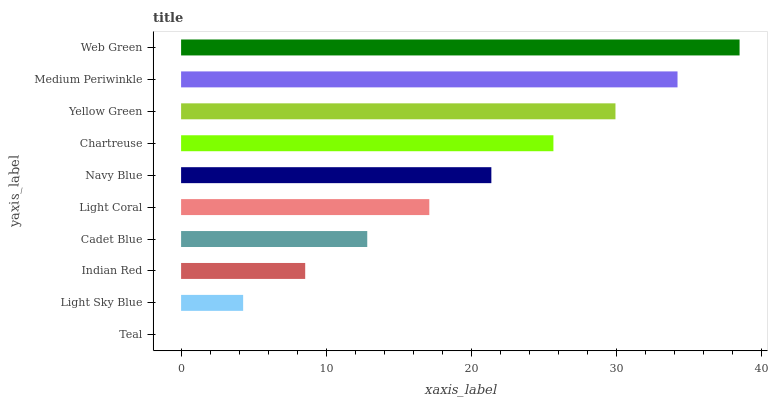Is Teal the minimum?
Answer yes or no. Yes. Is Web Green the maximum?
Answer yes or no. Yes. Is Light Sky Blue the minimum?
Answer yes or no. No. Is Light Sky Blue the maximum?
Answer yes or no. No. Is Light Sky Blue greater than Teal?
Answer yes or no. Yes. Is Teal less than Light Sky Blue?
Answer yes or no. Yes. Is Teal greater than Light Sky Blue?
Answer yes or no. No. Is Light Sky Blue less than Teal?
Answer yes or no. No. Is Navy Blue the high median?
Answer yes or no. Yes. Is Light Coral the low median?
Answer yes or no. Yes. Is Cadet Blue the high median?
Answer yes or no. No. Is Cadet Blue the low median?
Answer yes or no. No. 